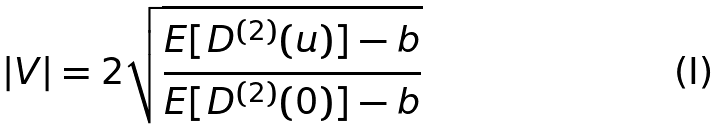<formula> <loc_0><loc_0><loc_500><loc_500>| V | = 2 \sqrt { \frac { E [ D ^ { ( 2 ) } ( u ) ] - b } { E [ D ^ { ( 2 ) } ( 0 ) ] - b } }</formula> 